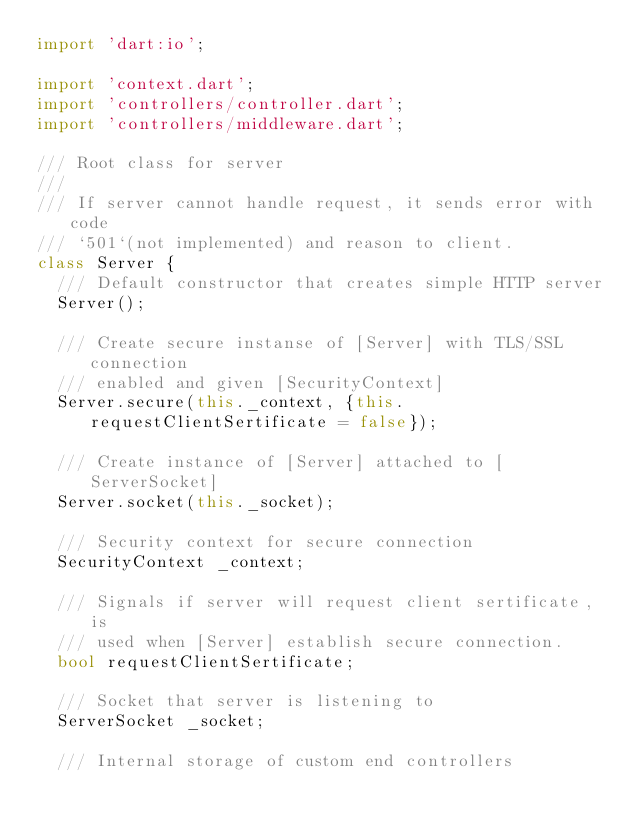Convert code to text. <code><loc_0><loc_0><loc_500><loc_500><_Dart_>import 'dart:io';

import 'context.dart';
import 'controllers/controller.dart';
import 'controllers/middleware.dart';

/// Root class for server
///
/// If server cannot handle request, it sends error with code
/// `501`(not implemented) and reason to client.
class Server {
  /// Default constructor that creates simple HTTP server
  Server();

  /// Create secure instanse of [Server] with TLS/SSL connection
  /// enabled and given [SecurityContext]
  Server.secure(this._context, {this.requestClientSertificate = false});

  /// Create instance of [Server] attached to [ServerSocket]
  Server.socket(this._socket);

  /// Security context for secure connection
  SecurityContext _context;

  /// Signals if server will request client sertificate, is
  /// used when [Server] establish secure connection.
  bool requestClientSertificate;

  /// Socket that server is listening to
  ServerSocket _socket;

  /// Internal storage of custom end controllers</code> 